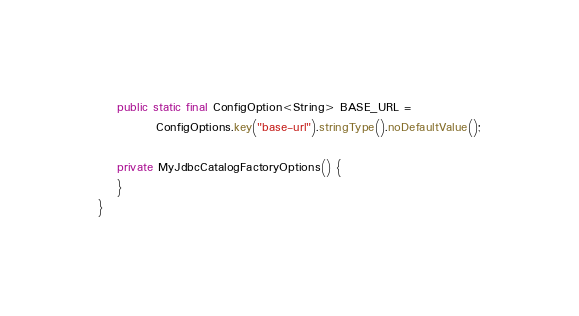<code> <loc_0><loc_0><loc_500><loc_500><_Java_>    public static final ConfigOption<String> BASE_URL =
            ConfigOptions.key("base-url").stringType().noDefaultValue();

    private MyJdbcCatalogFactoryOptions() {
    }
}
</code> 